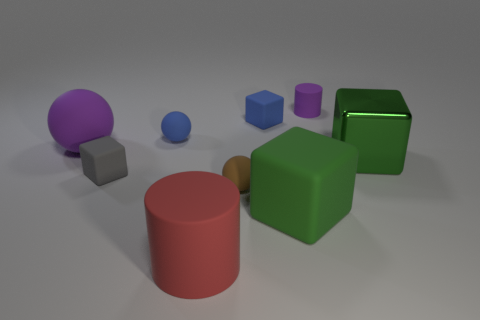Is the small rubber cylinder the same color as the big sphere?
Your response must be concise. Yes. There is a large purple thing that is left of the blue object that is on the left side of the large rubber cylinder; what number of things are on the right side of it?
Make the answer very short. 8. There is a large red thing that is the same material as the purple cylinder; what is its shape?
Offer a terse response. Cylinder. There is a large green block that is in front of the small object in front of the cube to the left of the small blue rubber sphere; what is it made of?
Offer a very short reply. Rubber. What number of objects are either things to the right of the large red thing or green cubes?
Your answer should be very brief. 5. How many other objects are the same shape as the red object?
Your answer should be very brief. 1. Is the number of small rubber balls that are to the right of the big purple object greater than the number of large green metal cubes?
Offer a terse response. Yes. The other rubber object that is the same shape as the big red matte object is what size?
Keep it short and to the point. Small. There is a small brown thing; what shape is it?
Give a very brief answer. Sphere. There is a gray thing that is the same size as the purple matte cylinder; what shape is it?
Your response must be concise. Cube. 